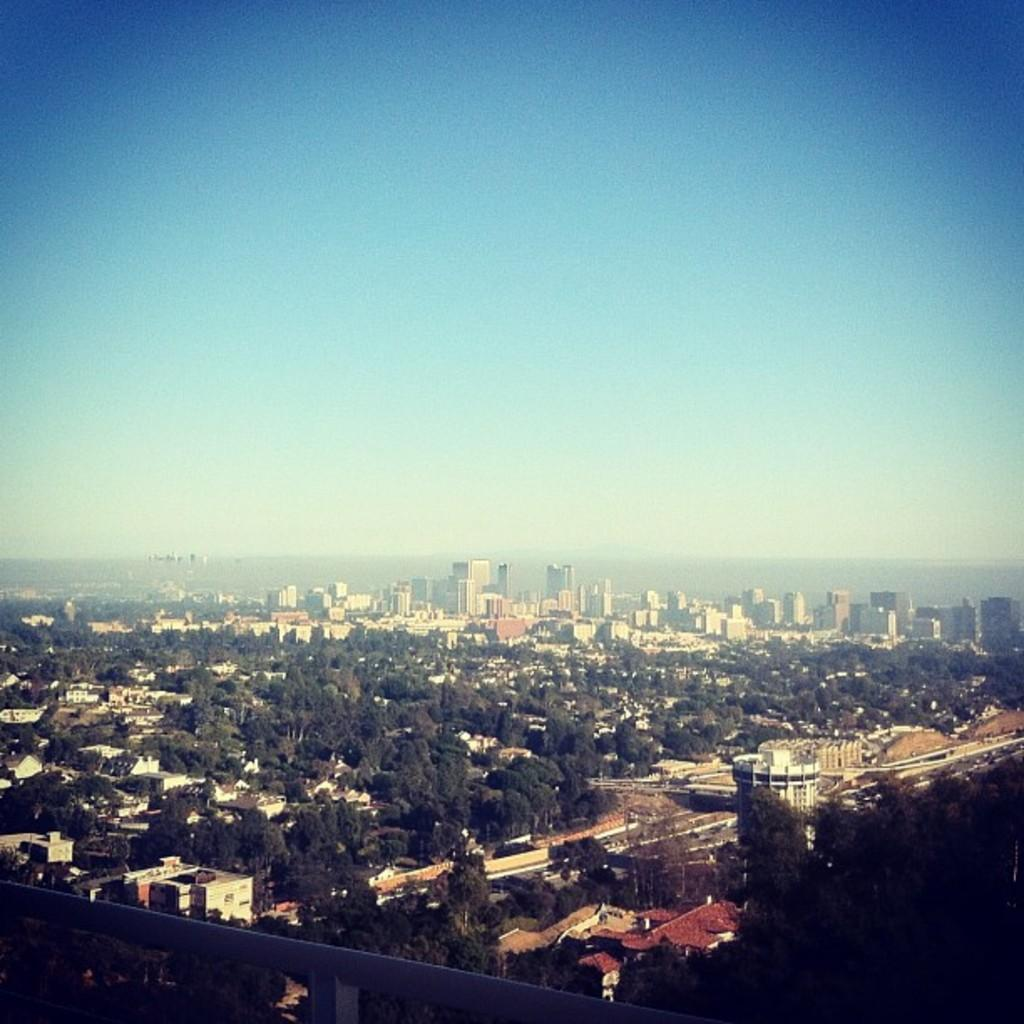What type of view is shown in the image? The image is an outside view. What can be seen at the bottom of the image? There are many trees and buildings at the bottom of the image. What is visible at the top of the image? The sky is visible at the top of the image. Can you see any magic happening in the image? There is no magic present in the image; it shows an outside view with trees, buildings, and the sky. 